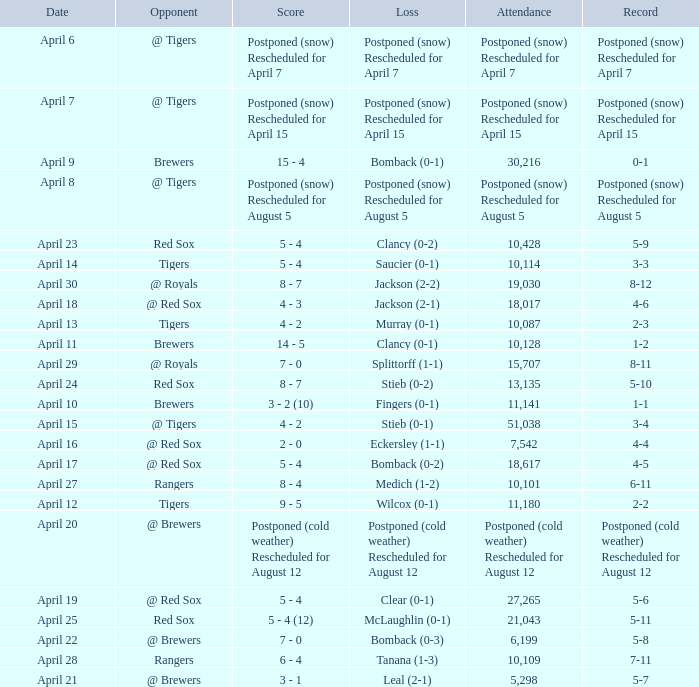What was the date for the game that had an attendance of 10,101? April 27. 